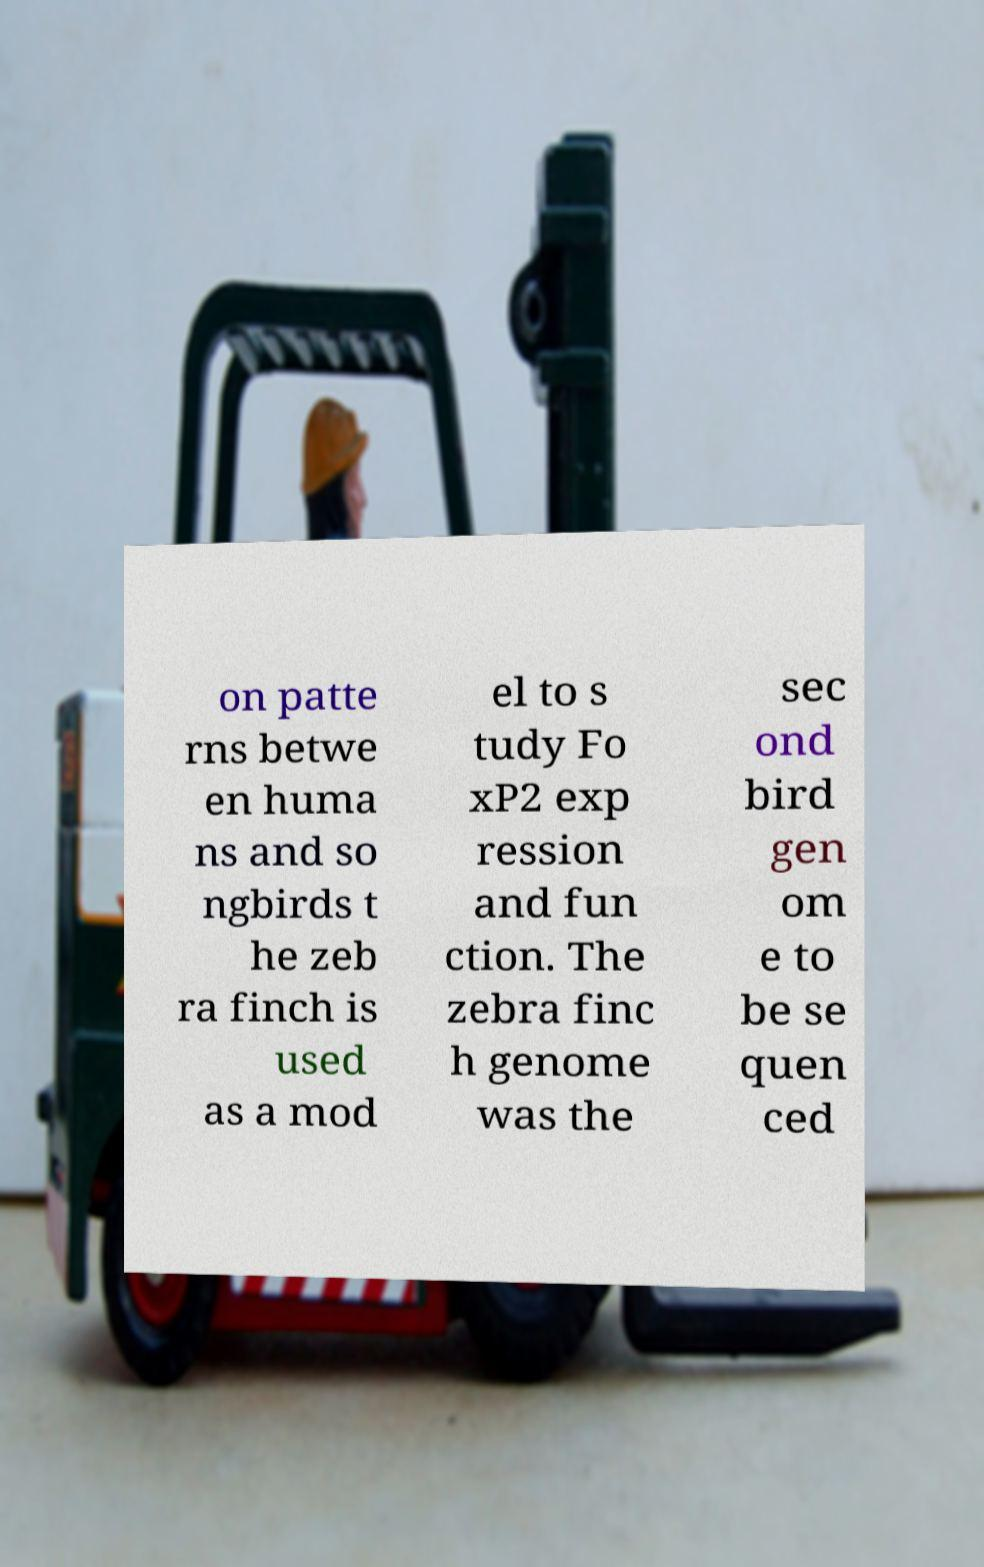For documentation purposes, I need the text within this image transcribed. Could you provide that? on patte rns betwe en huma ns and so ngbirds t he zeb ra finch is used as a mod el to s tudy Fo xP2 exp ression and fun ction. The zebra finc h genome was the sec ond bird gen om e to be se quen ced 